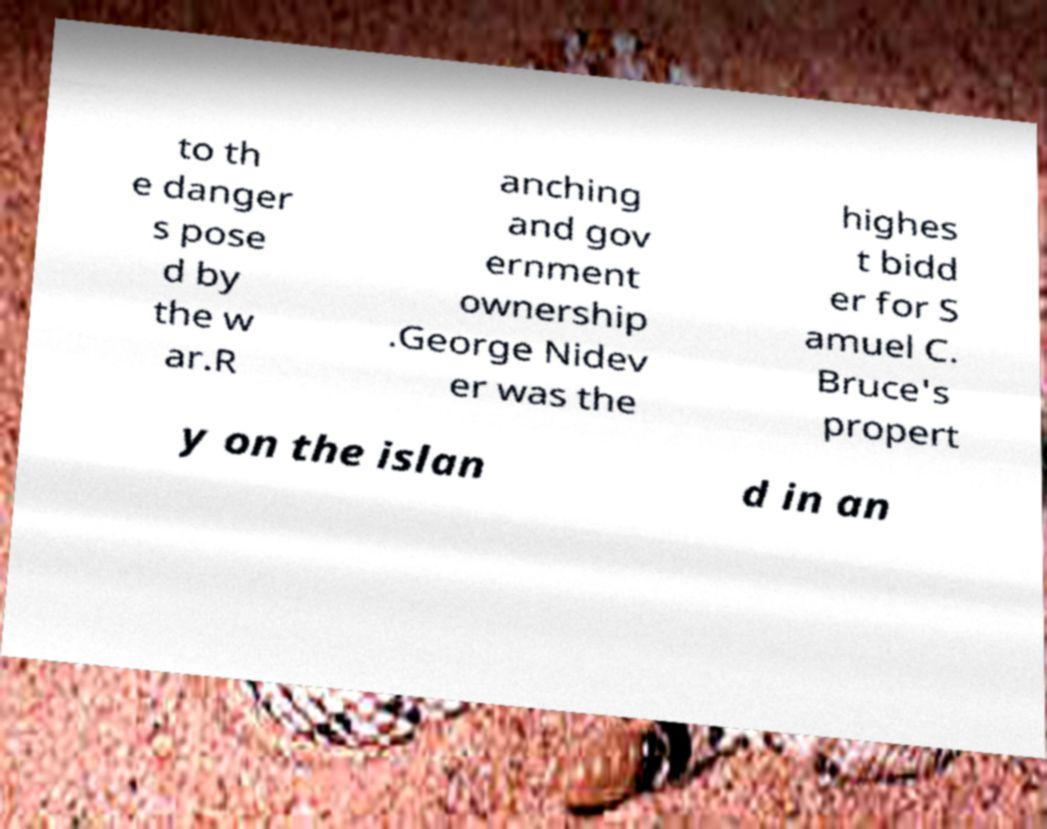For documentation purposes, I need the text within this image transcribed. Could you provide that? to th e danger s pose d by the w ar.R anching and gov ernment ownership .George Nidev er was the highes t bidd er for S amuel C. Bruce's propert y on the islan d in an 